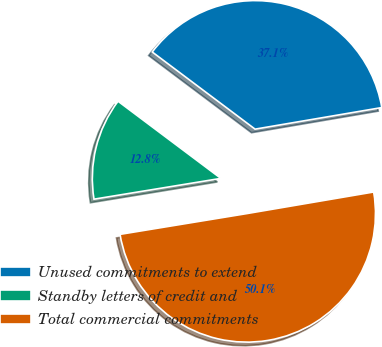Convert chart to OTSL. <chart><loc_0><loc_0><loc_500><loc_500><pie_chart><fcel>Unused commitments to extend<fcel>Standby letters of credit and<fcel>Total commercial commitments<nl><fcel>37.07%<fcel>12.83%<fcel>50.1%<nl></chart> 